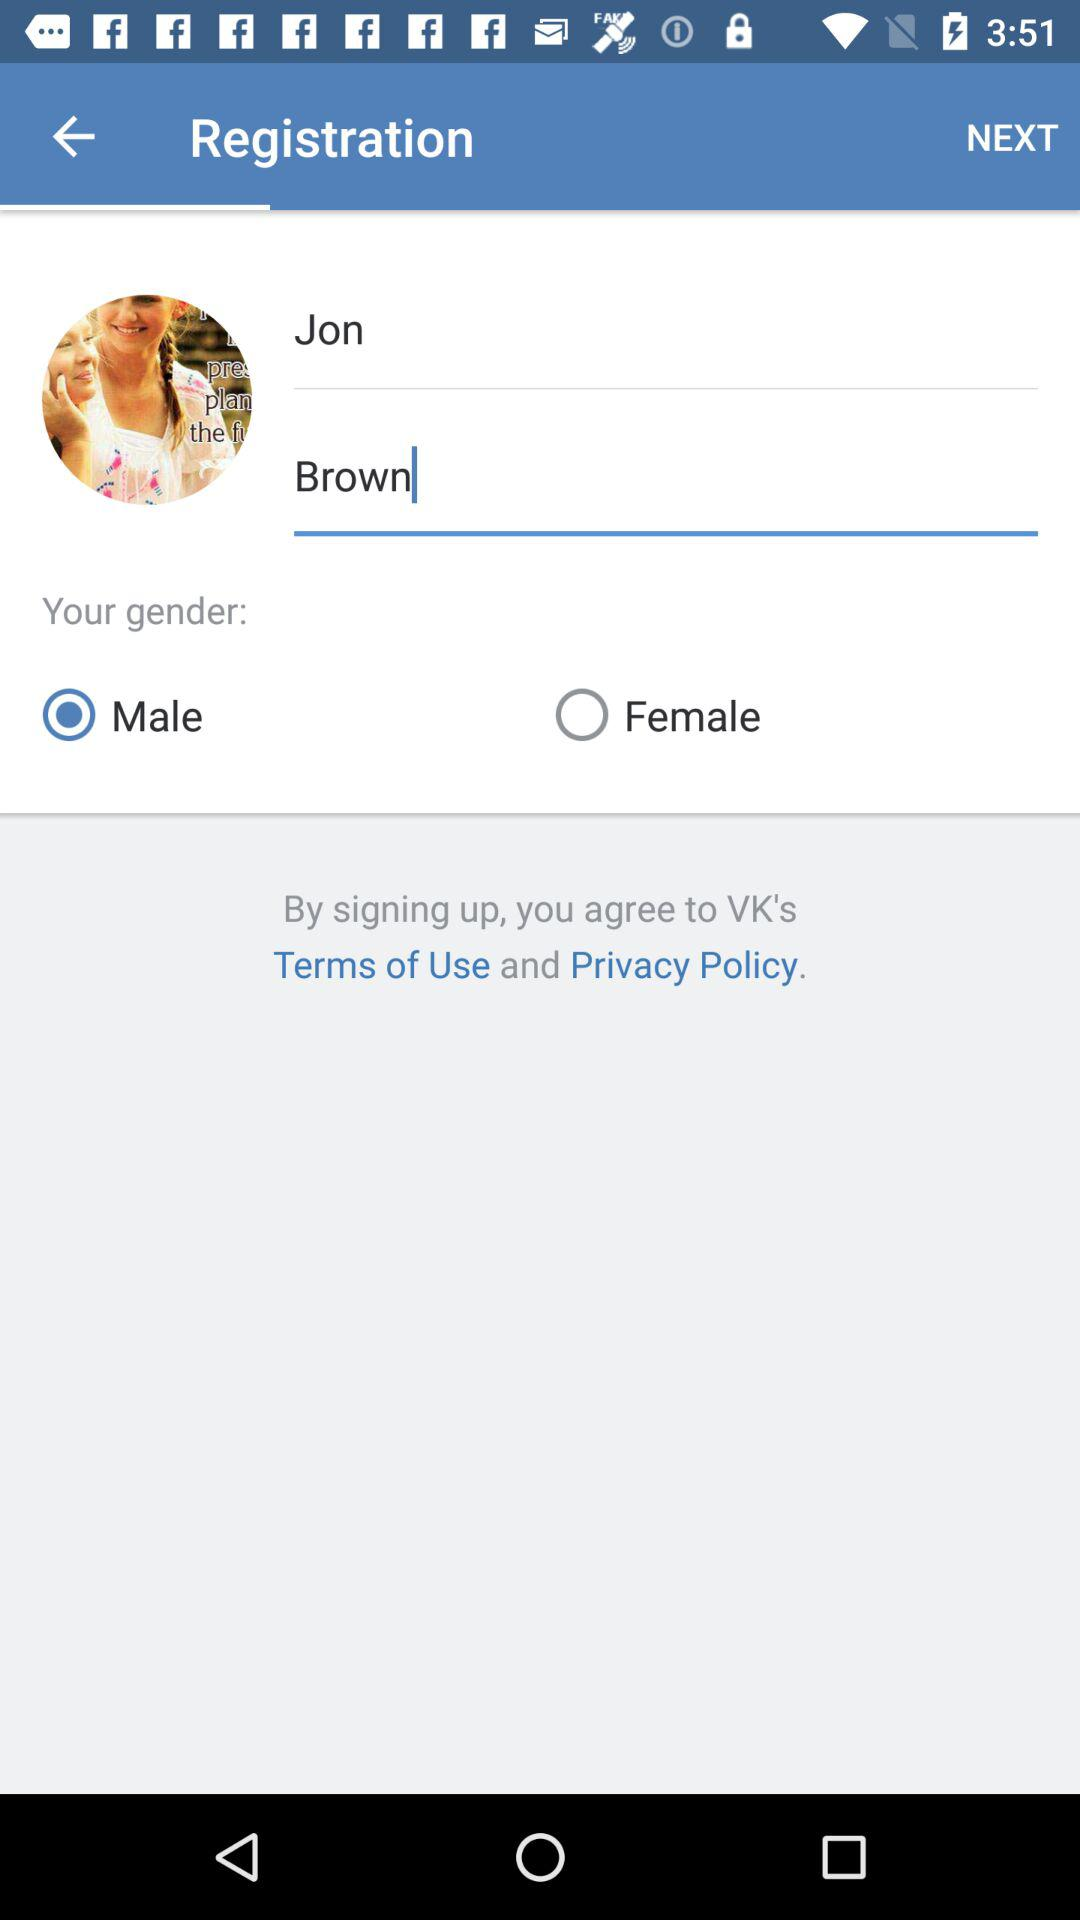How many fields are there to enter your name?
Answer the question using a single word or phrase. 2 